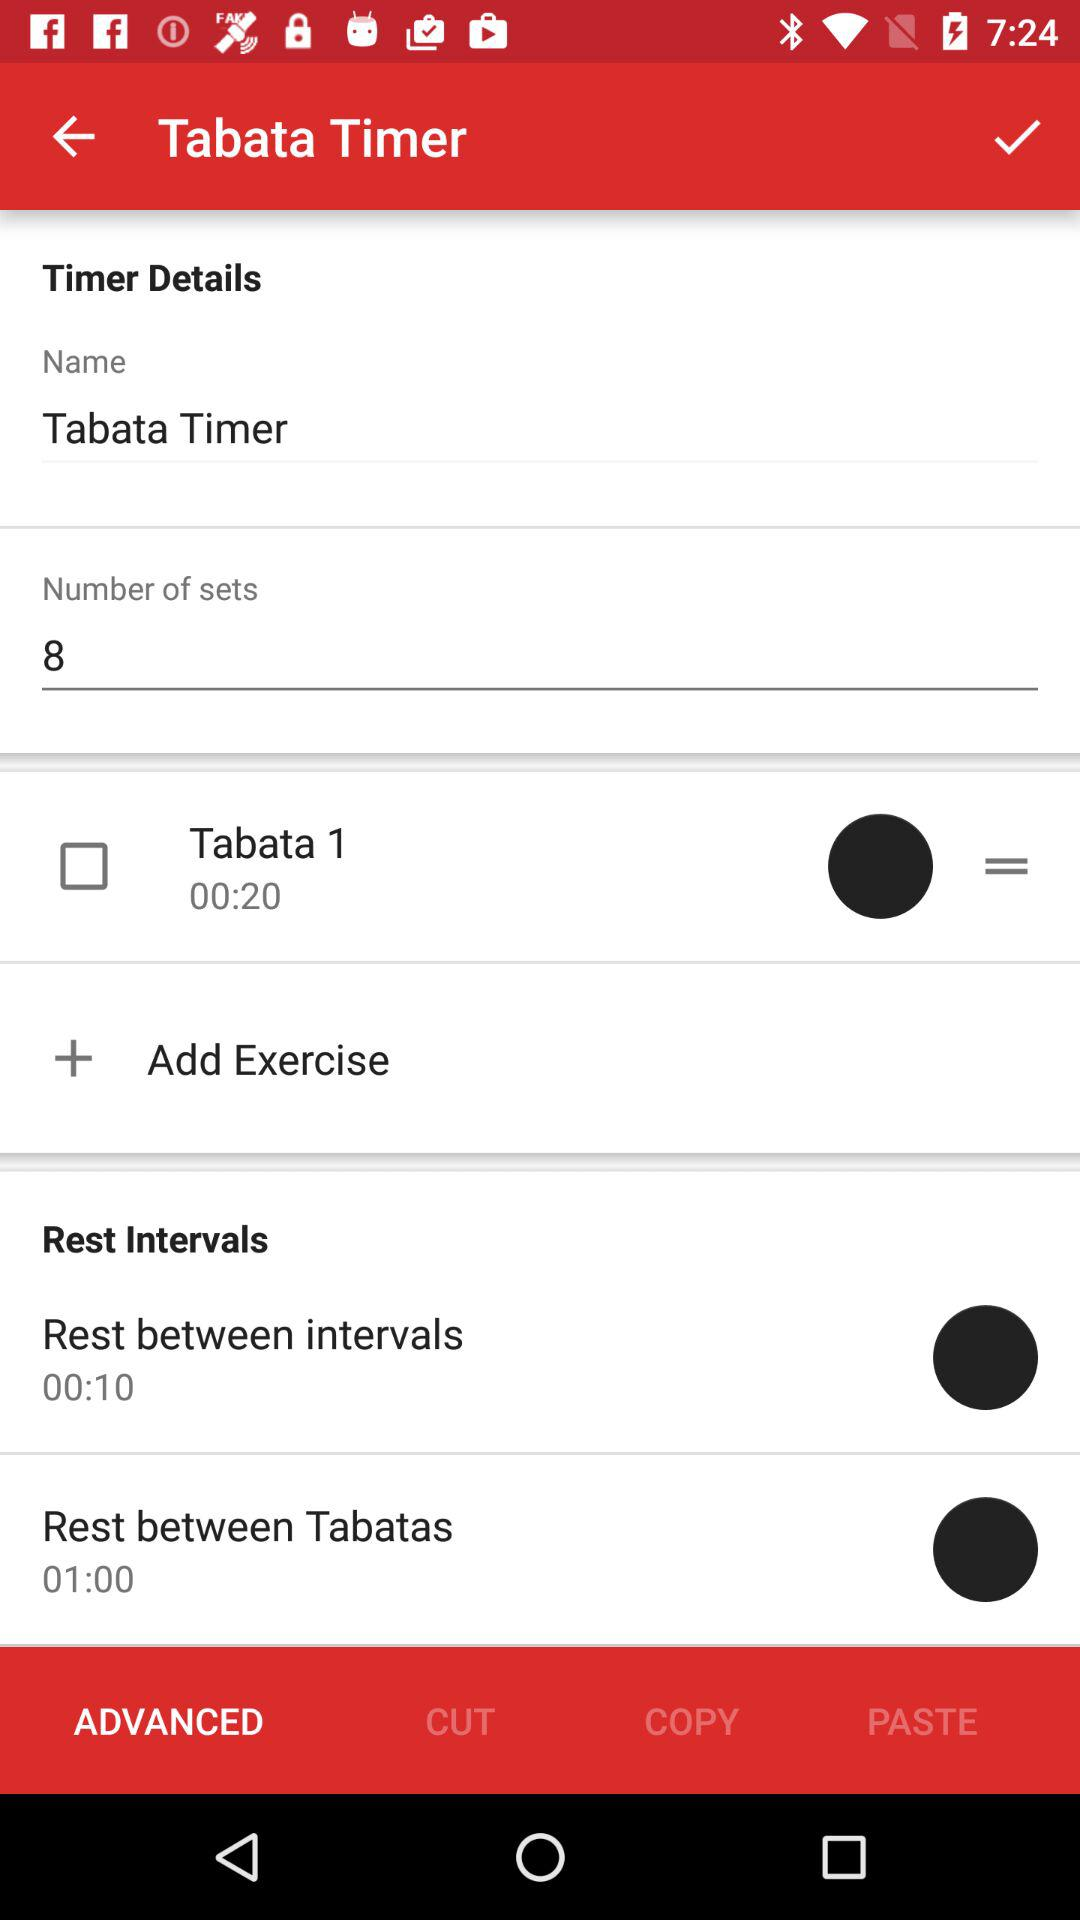How many sets are there? There are 8 sets. 